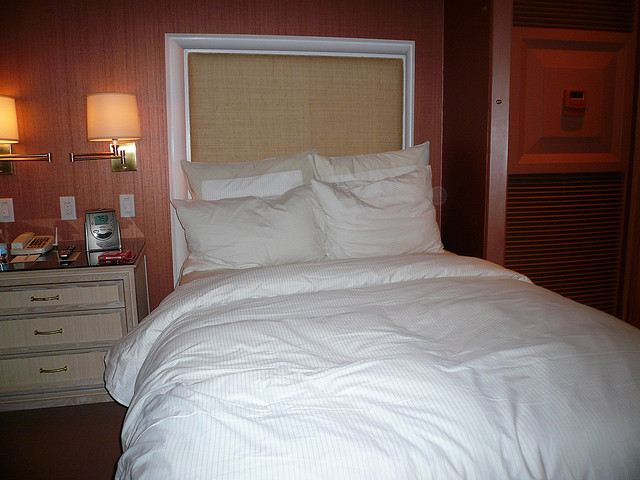Can you describe the lighting in the room? There are two lamps with a warm glow on either side of the bed, providing a soft, ambient light that enhances the cozy feel of the bedroom. The lampshades cast a gentle illumination that's conducive to relaxation. 